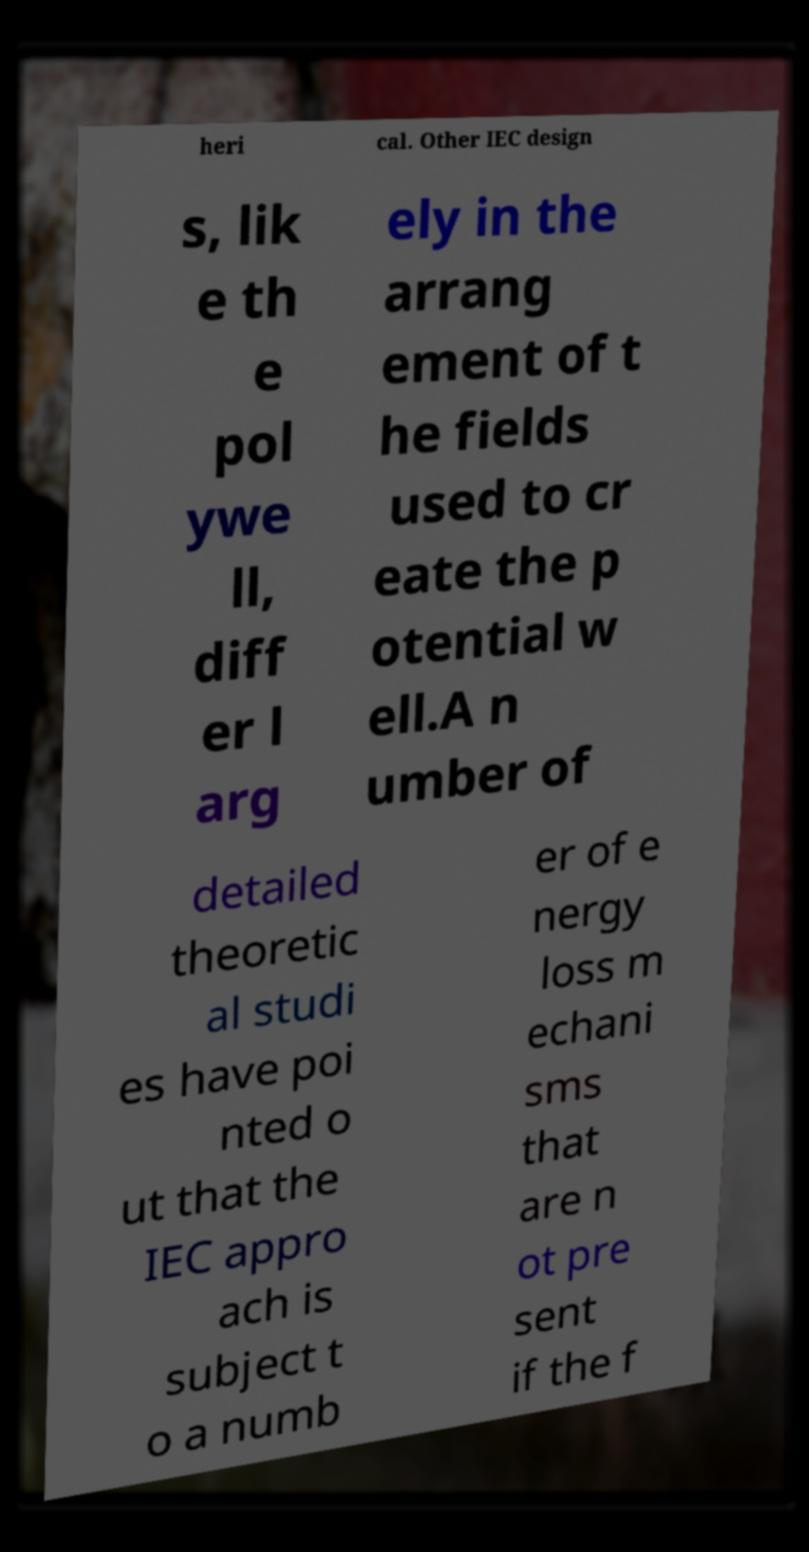For documentation purposes, I need the text within this image transcribed. Could you provide that? heri cal. Other IEC design s, lik e th e pol ywe ll, diff er l arg ely in the arrang ement of t he fields used to cr eate the p otential w ell.A n umber of detailed theoretic al studi es have poi nted o ut that the IEC appro ach is subject t o a numb er of e nergy loss m echani sms that are n ot pre sent if the f 